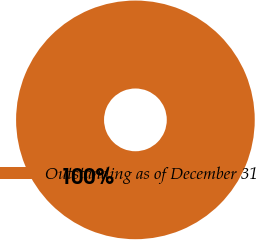Convert chart to OTSL. <chart><loc_0><loc_0><loc_500><loc_500><pie_chart><fcel>Outstanding as of December 31<nl><fcel>100.0%<nl></chart> 